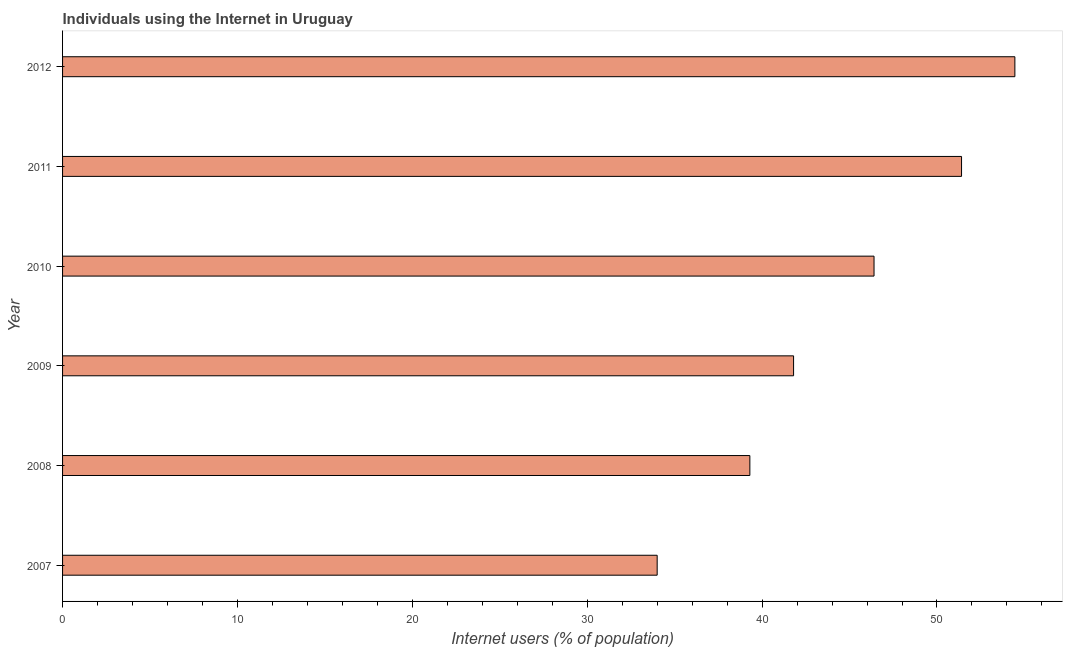Does the graph contain any zero values?
Your response must be concise. No. Does the graph contain grids?
Your answer should be very brief. No. What is the title of the graph?
Make the answer very short. Individuals using the Internet in Uruguay. What is the label or title of the X-axis?
Your response must be concise. Internet users (% of population). What is the label or title of the Y-axis?
Ensure brevity in your answer.  Year. What is the number of internet users in 2012?
Give a very brief answer. 54.45. Across all years, what is the maximum number of internet users?
Your answer should be compact. 54.45. In which year was the number of internet users minimum?
Give a very brief answer. 2007. What is the sum of the number of internet users?
Make the answer very short. 267.36. What is the difference between the number of internet users in 2011 and 2012?
Your answer should be very brief. -3.05. What is the average number of internet users per year?
Your response must be concise. 44.56. What is the median number of internet users?
Ensure brevity in your answer.  44.1. In how many years, is the number of internet users greater than 48 %?
Provide a succinct answer. 2. What is the ratio of the number of internet users in 2009 to that in 2011?
Offer a terse response. 0.81. What is the difference between the highest and the second highest number of internet users?
Offer a terse response. 3.05. What is the difference between the highest and the lowest number of internet users?
Your answer should be compact. 20.45. How many bars are there?
Your response must be concise. 6. Are all the bars in the graph horizontal?
Provide a succinct answer. Yes. What is the difference between two consecutive major ticks on the X-axis?
Offer a terse response. 10. Are the values on the major ticks of X-axis written in scientific E-notation?
Offer a very short reply. No. What is the Internet users (% of population) of 2007?
Provide a short and direct response. 34. What is the Internet users (% of population) of 2008?
Provide a succinct answer. 39.3. What is the Internet users (% of population) in 2009?
Your answer should be very brief. 41.8. What is the Internet users (% of population) of 2010?
Provide a short and direct response. 46.4. What is the Internet users (% of population) in 2011?
Ensure brevity in your answer.  51.4. What is the Internet users (% of population) of 2012?
Provide a succinct answer. 54.45. What is the difference between the Internet users (% of population) in 2007 and 2009?
Your response must be concise. -7.8. What is the difference between the Internet users (% of population) in 2007 and 2011?
Give a very brief answer. -17.4. What is the difference between the Internet users (% of population) in 2007 and 2012?
Make the answer very short. -20.45. What is the difference between the Internet users (% of population) in 2008 and 2011?
Your answer should be very brief. -12.1. What is the difference between the Internet users (% of population) in 2008 and 2012?
Your answer should be very brief. -15.15. What is the difference between the Internet users (% of population) in 2009 and 2010?
Make the answer very short. -4.6. What is the difference between the Internet users (% of population) in 2009 and 2011?
Provide a succinct answer. -9.6. What is the difference between the Internet users (% of population) in 2009 and 2012?
Ensure brevity in your answer.  -12.65. What is the difference between the Internet users (% of population) in 2010 and 2011?
Ensure brevity in your answer.  -5. What is the difference between the Internet users (% of population) in 2010 and 2012?
Make the answer very short. -8.05. What is the difference between the Internet users (% of population) in 2011 and 2012?
Offer a very short reply. -3.05. What is the ratio of the Internet users (% of population) in 2007 to that in 2008?
Your answer should be very brief. 0.86. What is the ratio of the Internet users (% of population) in 2007 to that in 2009?
Give a very brief answer. 0.81. What is the ratio of the Internet users (% of population) in 2007 to that in 2010?
Ensure brevity in your answer.  0.73. What is the ratio of the Internet users (% of population) in 2007 to that in 2011?
Your answer should be compact. 0.66. What is the ratio of the Internet users (% of population) in 2007 to that in 2012?
Give a very brief answer. 0.62. What is the ratio of the Internet users (% of population) in 2008 to that in 2009?
Your response must be concise. 0.94. What is the ratio of the Internet users (% of population) in 2008 to that in 2010?
Ensure brevity in your answer.  0.85. What is the ratio of the Internet users (% of population) in 2008 to that in 2011?
Provide a short and direct response. 0.77. What is the ratio of the Internet users (% of population) in 2008 to that in 2012?
Offer a terse response. 0.72. What is the ratio of the Internet users (% of population) in 2009 to that in 2010?
Your answer should be very brief. 0.9. What is the ratio of the Internet users (% of population) in 2009 to that in 2011?
Provide a succinct answer. 0.81. What is the ratio of the Internet users (% of population) in 2009 to that in 2012?
Your answer should be compact. 0.77. What is the ratio of the Internet users (% of population) in 2010 to that in 2011?
Keep it short and to the point. 0.9. What is the ratio of the Internet users (% of population) in 2010 to that in 2012?
Provide a short and direct response. 0.85. What is the ratio of the Internet users (% of population) in 2011 to that in 2012?
Your answer should be very brief. 0.94. 